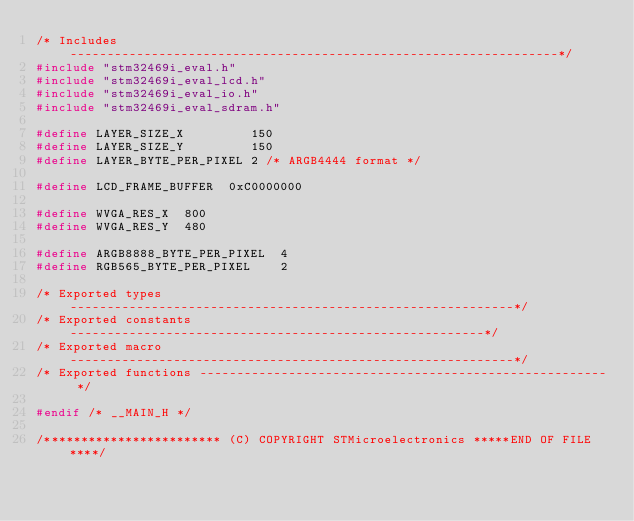<code> <loc_0><loc_0><loc_500><loc_500><_C_>/* Includes ------------------------------------------------------------------*/
#include "stm32469i_eval.h"
#include "stm32469i_eval_lcd.h"
#include "stm32469i_eval_io.h"
#include "stm32469i_eval_sdram.h"

#define LAYER_SIZE_X         150
#define LAYER_SIZE_Y         150
#define LAYER_BYTE_PER_PIXEL 2 /* ARGB4444 format */

#define LCD_FRAME_BUFFER  0xC0000000

#define WVGA_RES_X  800
#define WVGA_RES_Y  480

#define ARGB8888_BYTE_PER_PIXEL  4
#define RGB565_BYTE_PER_PIXEL    2

/* Exported types ------------------------------------------------------------*/
/* Exported constants --------------------------------------------------------*/
/* Exported macro ------------------------------------------------------------*/
/* Exported functions ------------------------------------------------------- */

#endif /* __MAIN_H */

/************************ (C) COPYRIGHT STMicroelectronics *****END OF FILE****/
</code> 